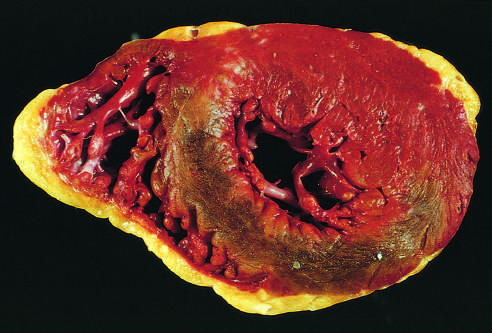s the posterior wall at the top?
Answer the question using a single word or phrase. Yes 